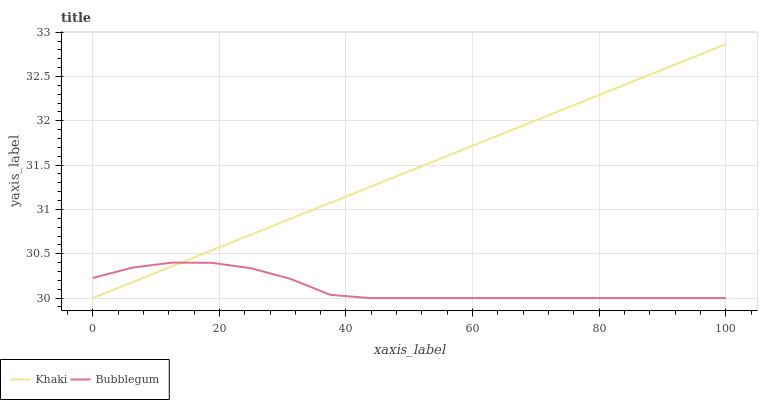Does Bubblegum have the minimum area under the curve?
Answer yes or no. Yes. Does Khaki have the maximum area under the curve?
Answer yes or no. Yes. Does Bubblegum have the maximum area under the curve?
Answer yes or no. No. Is Khaki the smoothest?
Answer yes or no. Yes. Is Bubblegum the roughest?
Answer yes or no. Yes. Is Bubblegum the smoothest?
Answer yes or no. No. Does Khaki have the highest value?
Answer yes or no. Yes. Does Bubblegum have the highest value?
Answer yes or no. No. Does Bubblegum intersect Khaki?
Answer yes or no. Yes. Is Bubblegum less than Khaki?
Answer yes or no. No. Is Bubblegum greater than Khaki?
Answer yes or no. No. 